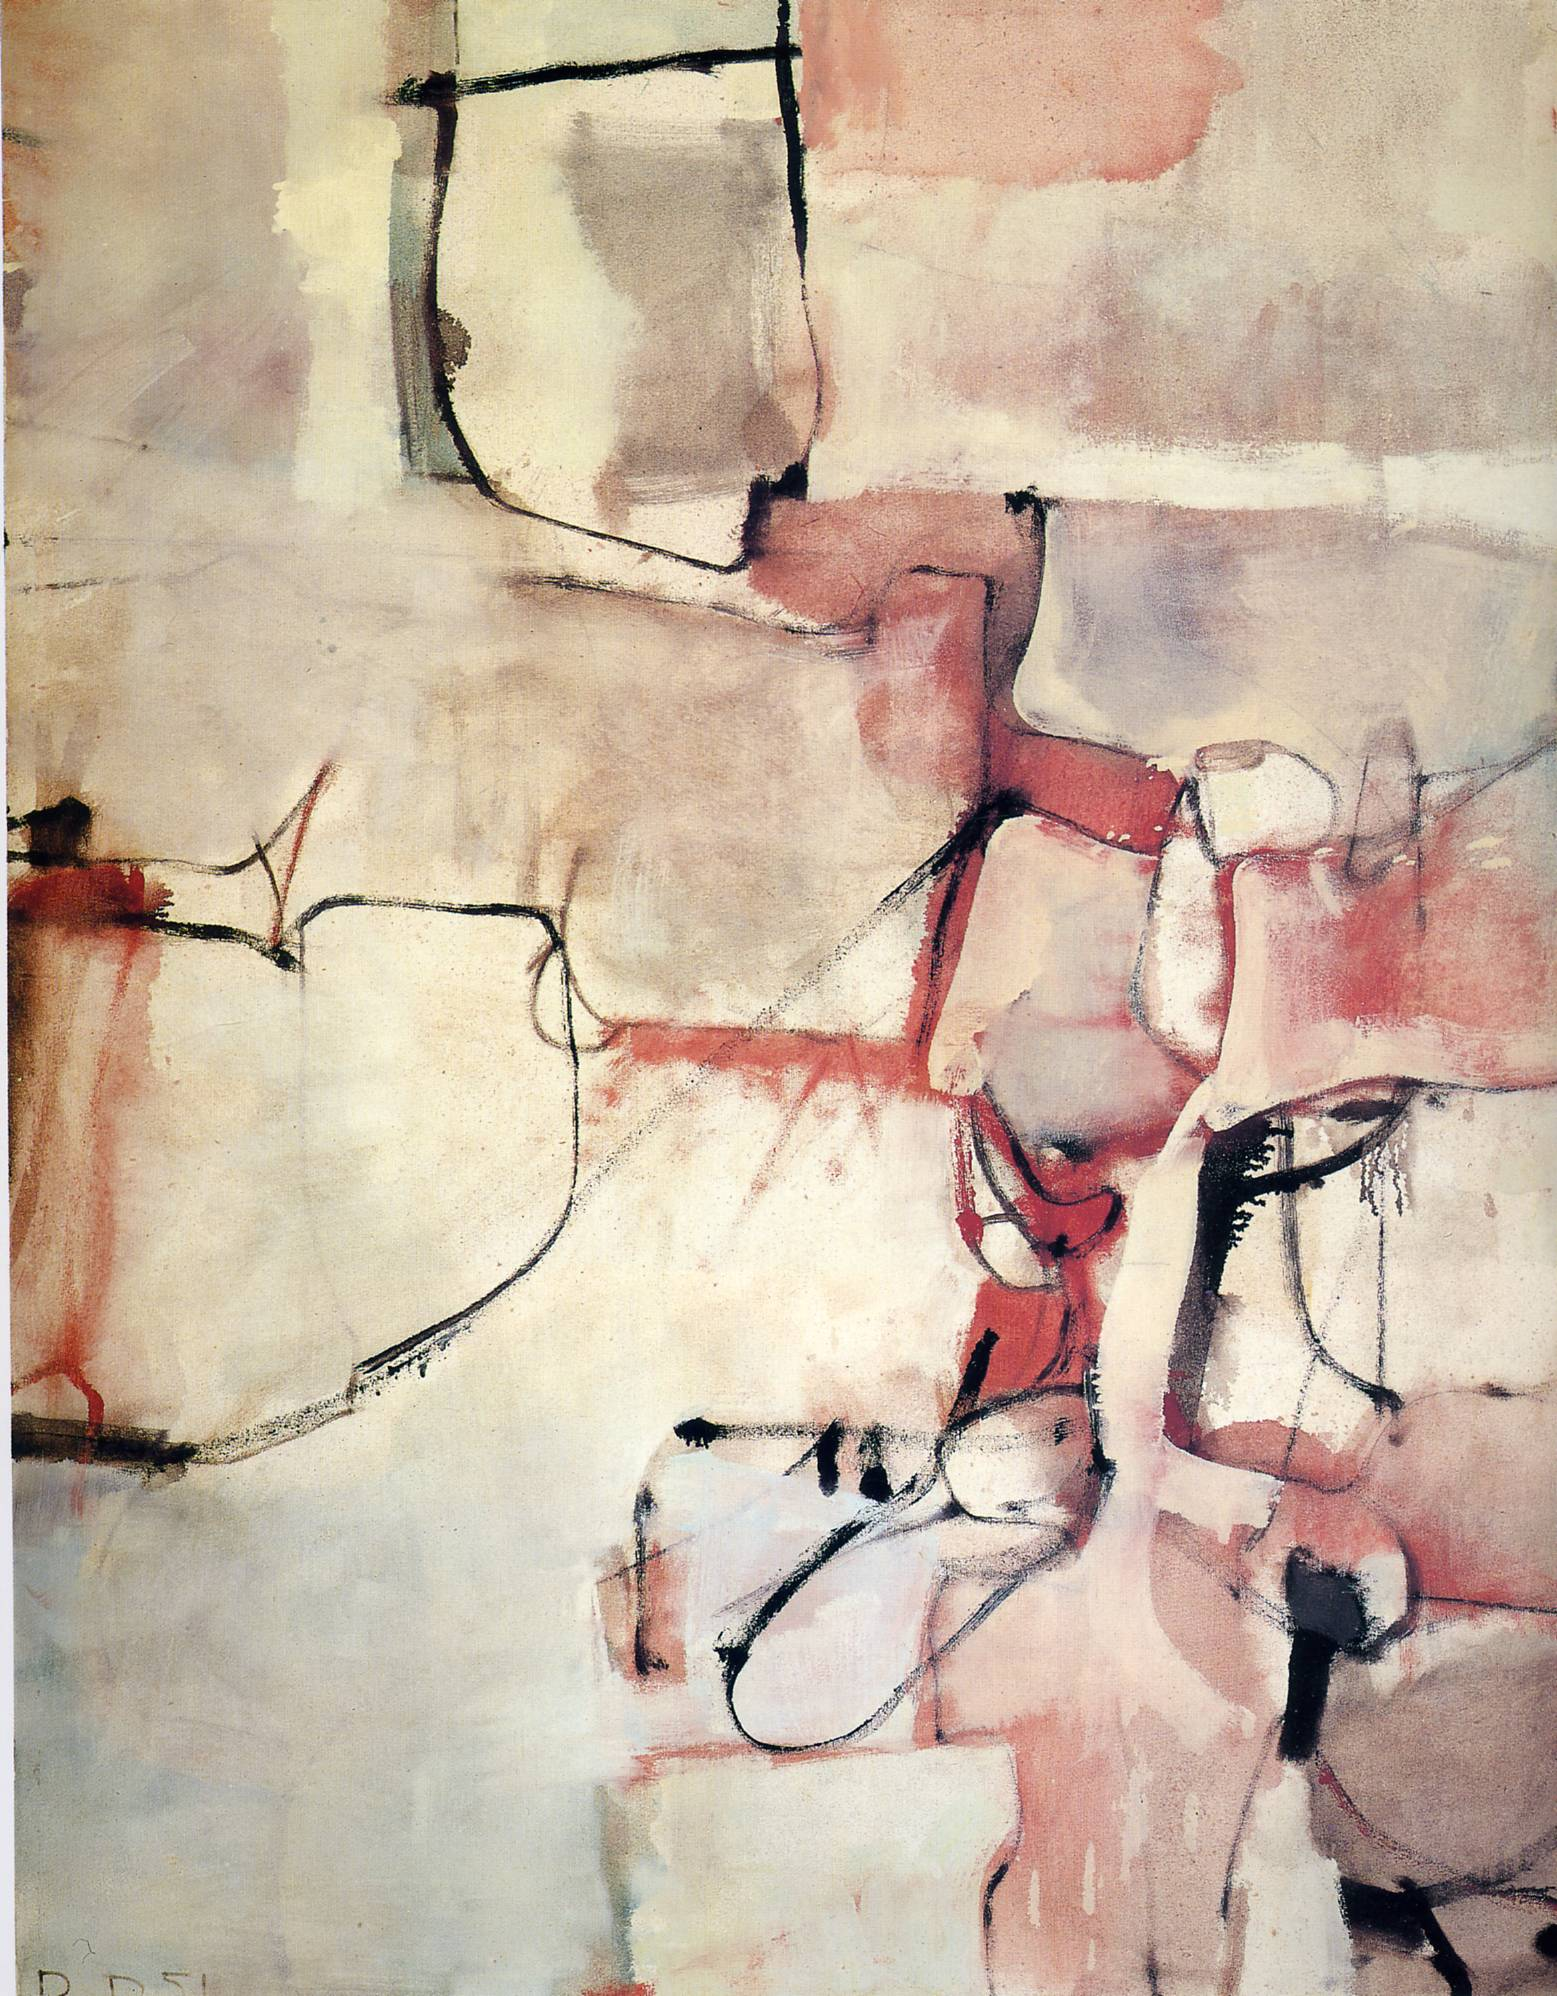Write a detailed description of the given image. The image presented is an intriguing abstract artwork. The color palette is predominated by warm tones such as red, pink, and beige, contributing to an inviting and soft aesthetic. The style evokes cubism with its geometric forms and intersecting lines, hinting at various perspectives and dimensions. 

In this piece, abstract expressionism is strongly evident. The use of color and form seems to convey a deep emotional resonance, as the lines—mostly bold in black with sporadic touches of red and pink—interact dynamically with one another and the shapes they define. Beige shapes form the primary structure, with vibrant areas of red and pink adding depth and layers to the composition.

Noteworthy is the deliberate use of blank spaces, which contrast vividly with the more densely illustrated areas, adding balance and elevating the overall visual texture. The artwork, therefore, is a fascinating study of abstract principles, expertly balancing form, color, and emotion to encapsulate a bold yet intricate narrative. 